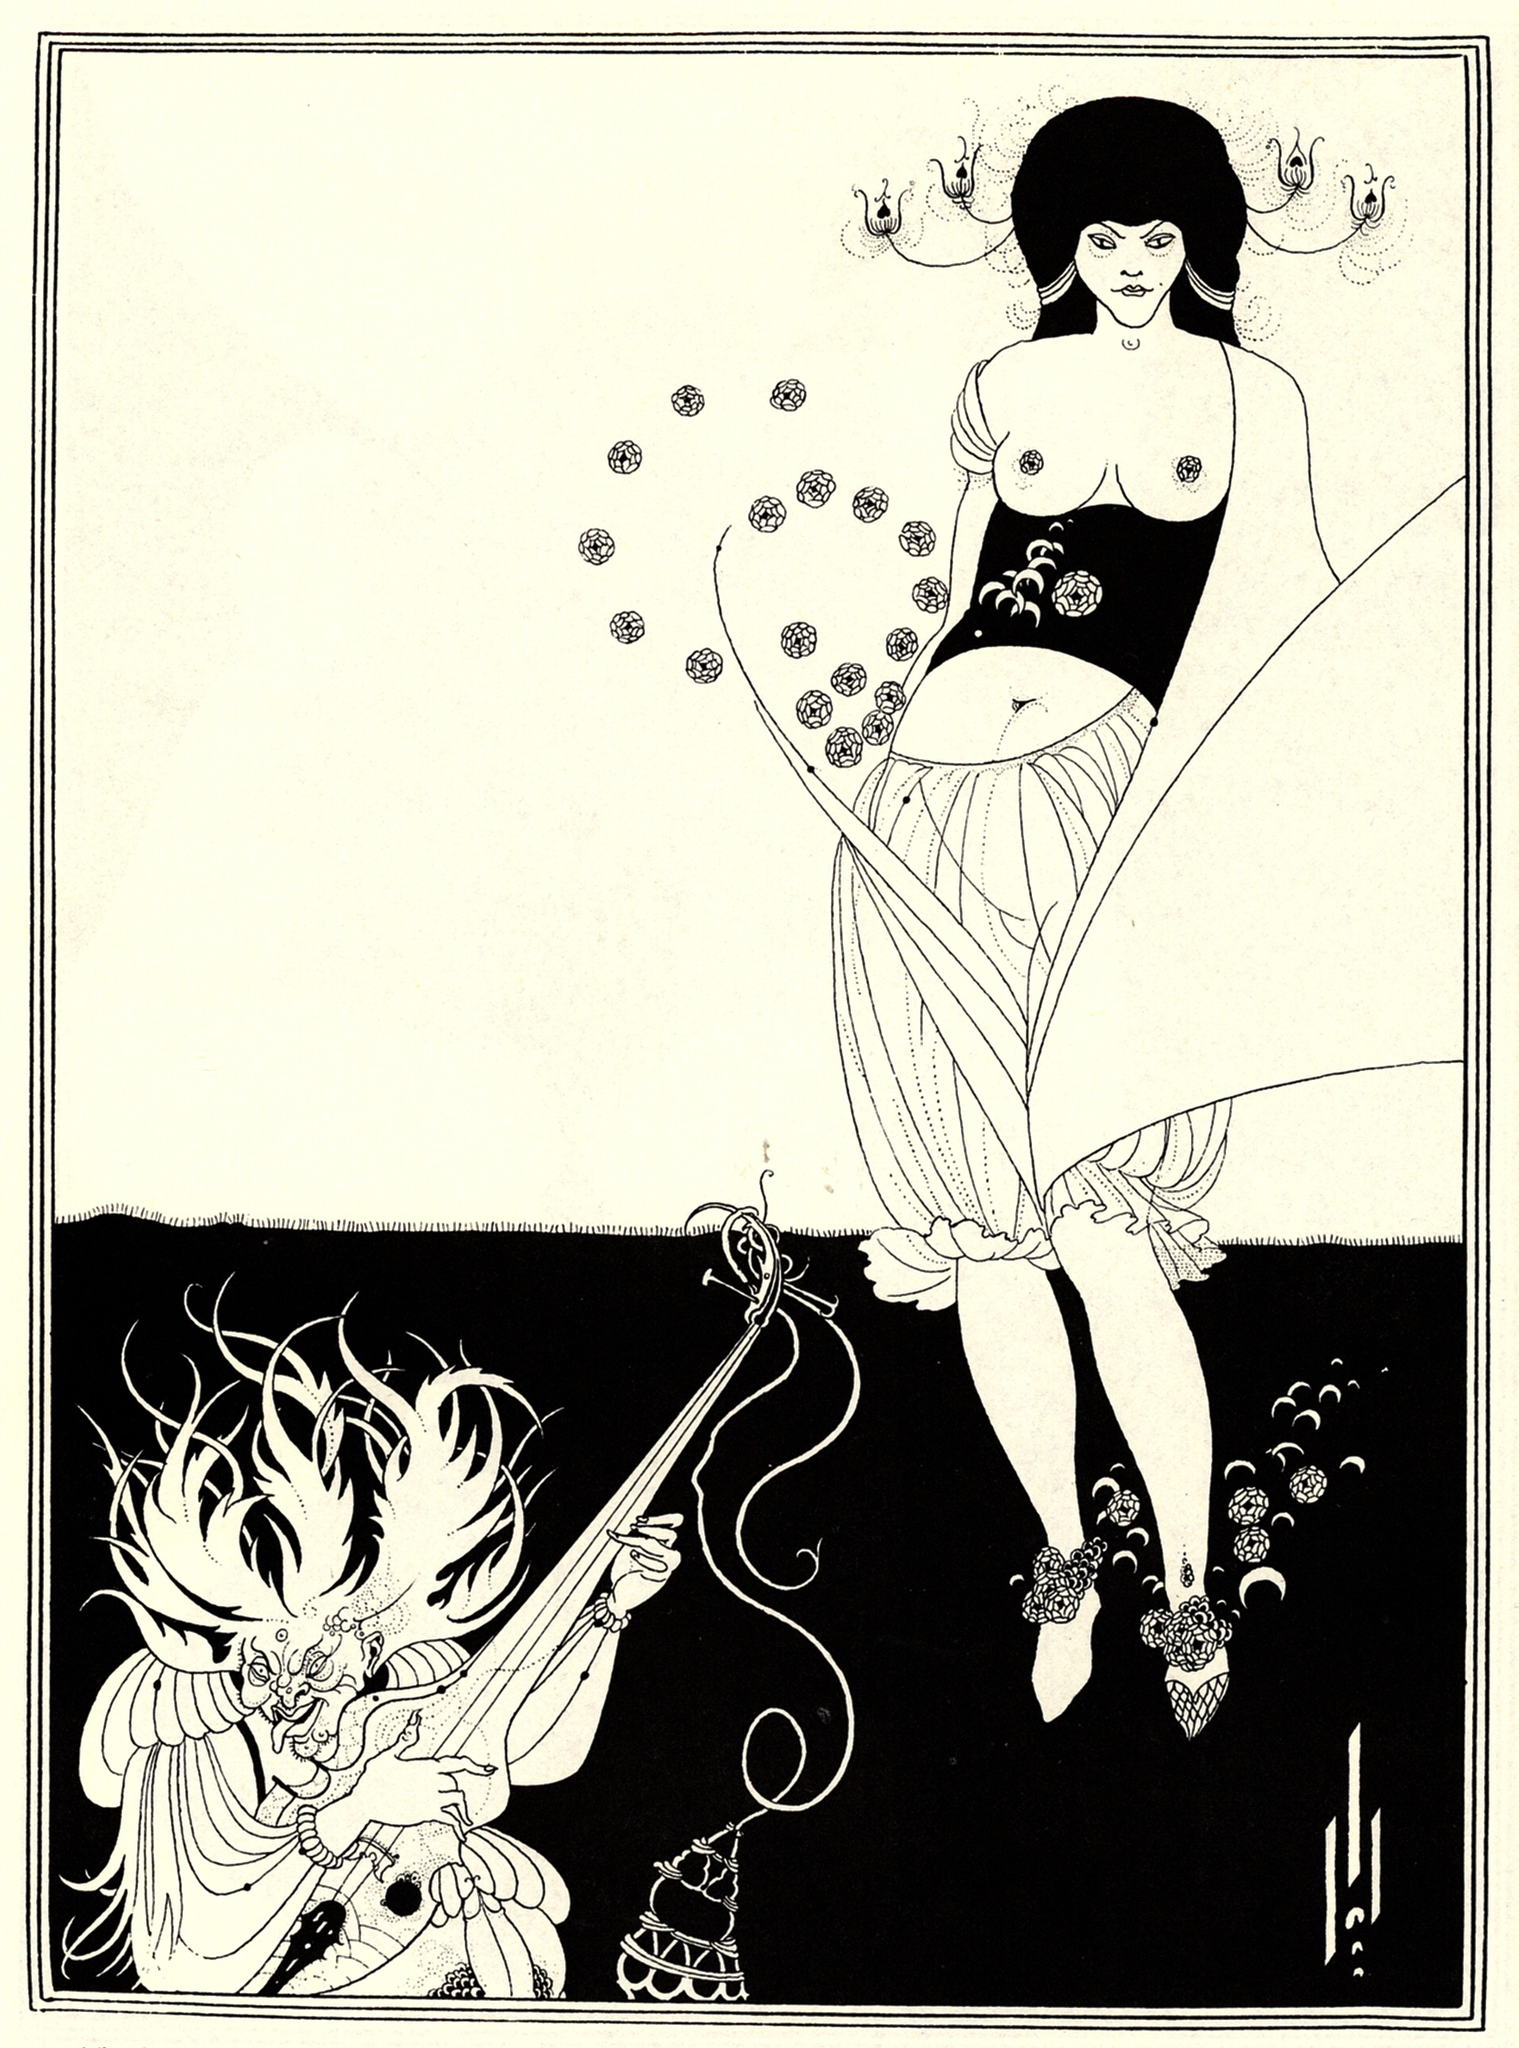What if you were part of this scene? How would you interact with the characters? If I were part of this scene, I would approach the woman with curiosity and respect, intrigued by her command of both elegance and power. As a mediator, I would seek to understand the wisdom she carries and learn about the dragon's ancient lore. My role would be to aid in their quest, perhaps by offering insights or discovering hidden paths, ultimately helping to weave the story’s tapestry with courage and empathy.  Suppose this artwork was a performance instead. What kind of music would accompany it? If this artwork were transformed into a performance, it would be accompanied by a hauntingly beautiful orchestral score, blending classical instruments with ethereal, mystical tones. The music would feature soaring violins symbolizing the woman’s grace and fluidity, while deep, resonant drums and horns would capture the dragon’s power and presence. Occasional chimes and flutes would represent the delicate and intricate details within the artwork, creating a harmonious and immersive auditory experience that mirrors the visual intricacies of the scene. 